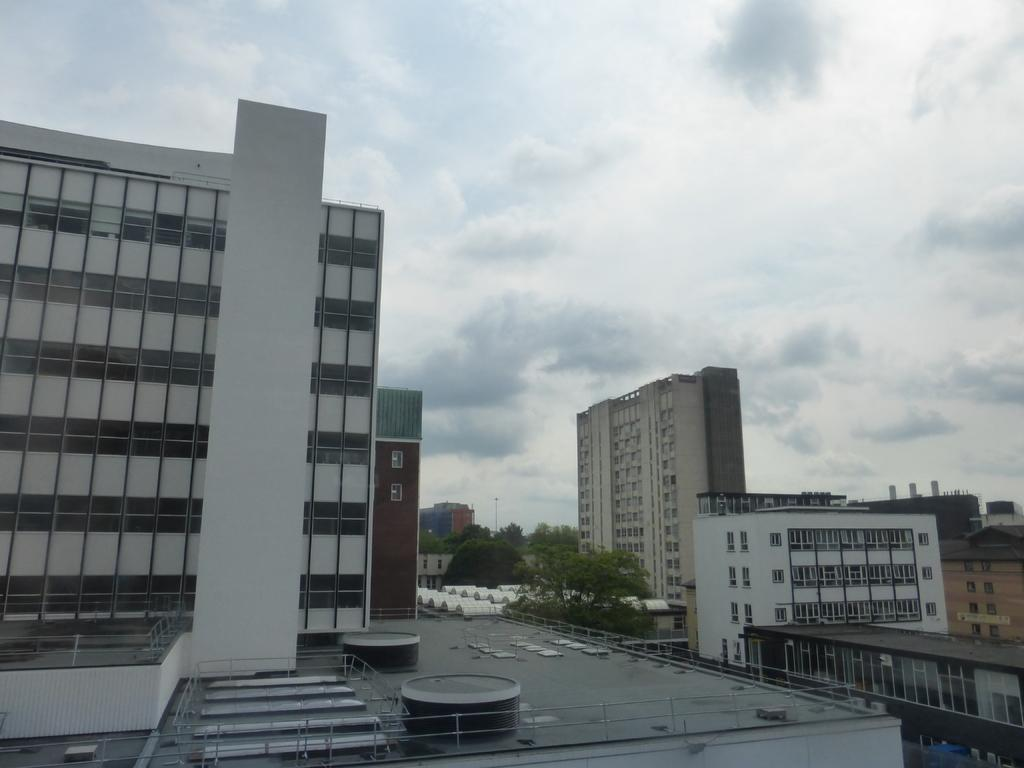What type of structures can be seen in the image? There are buildings in the image. What other natural elements are present in the image? There are trees in the image. How would you describe the weather in the image? The sky is cloudy in the image, suggesting a potentially overcast or cloudy day. What sound can be heard coming from the crow in the image? There is no crow present in the image, so it is not possible to determine what sound might be heard. 